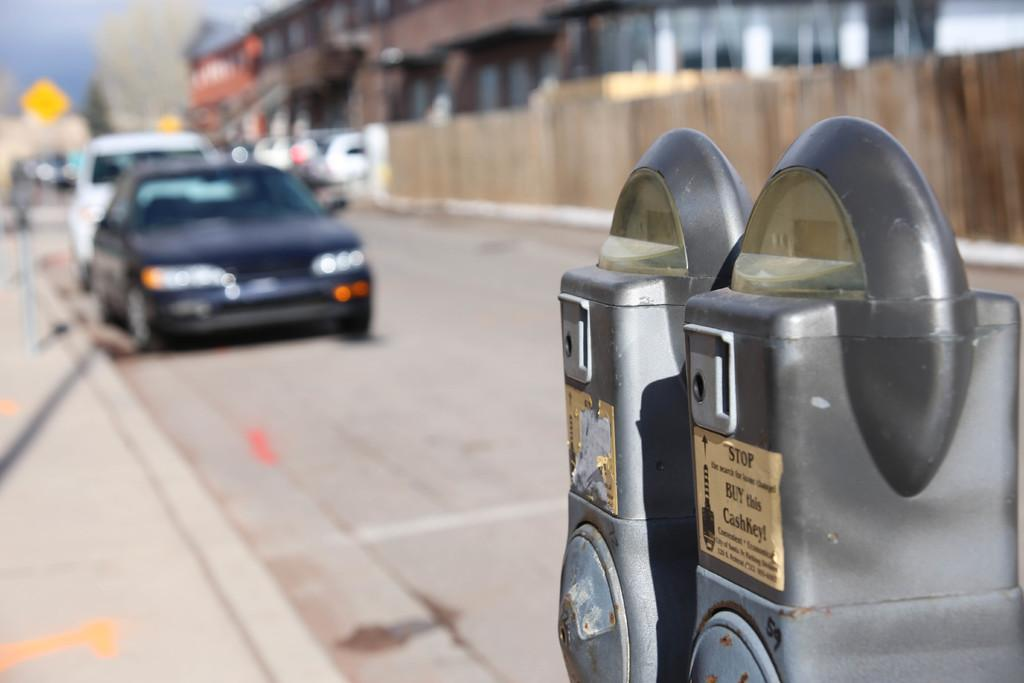What can be seen in the image? There are vehicles in the image. Where is the parking machine located in the image? The parking machine is on the right side of the image. What is visible in the background of the image? There are buildings in the background of the image. How many snakes are slithering on the parking machine in the image? There are no snakes present in the image; the parking machine is not associated with any snakes. 